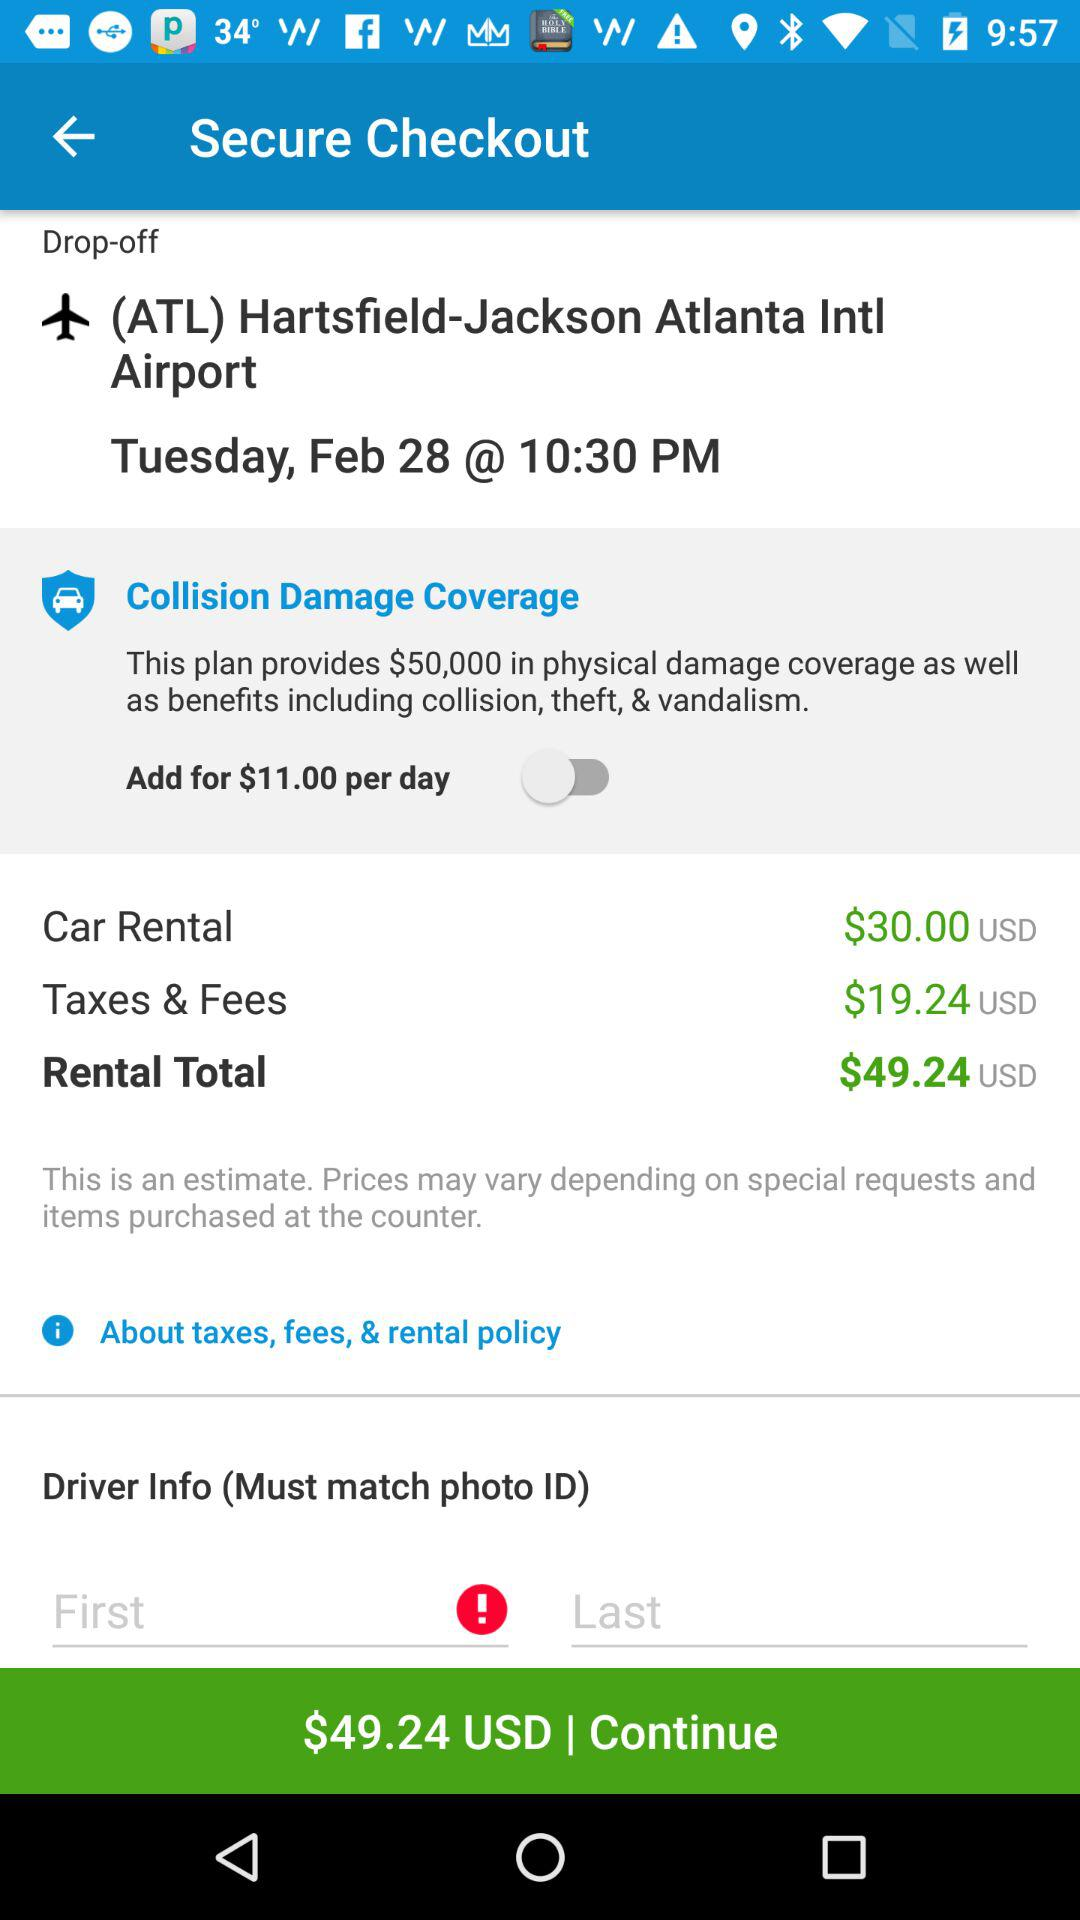What is the date and time? The date and time are Tuesday, February 28 and 10:30 PM, respectively. 